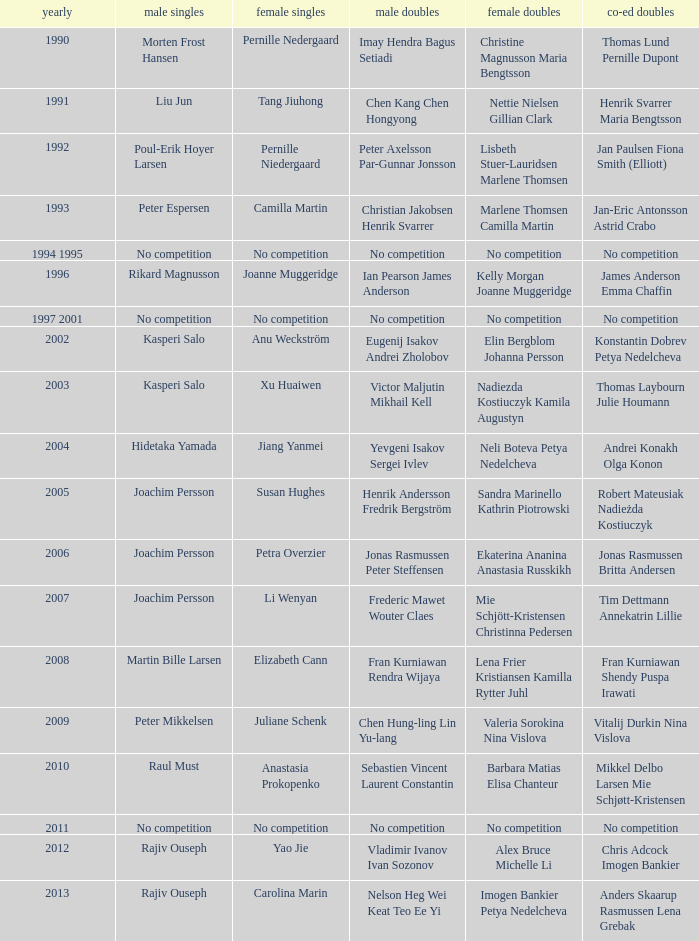Who won the Mixed doubles when Juliane Schenk won the Women's Singles? Vitalij Durkin Nina Vislova. 